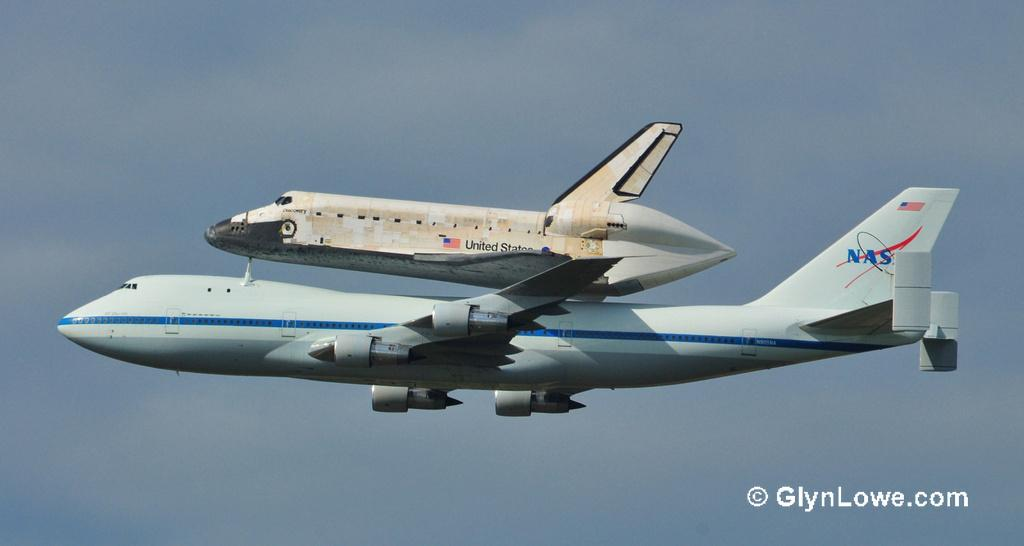<image>
Summarize the visual content of the image. The US space shuttle is being carried by a NASA plane. 